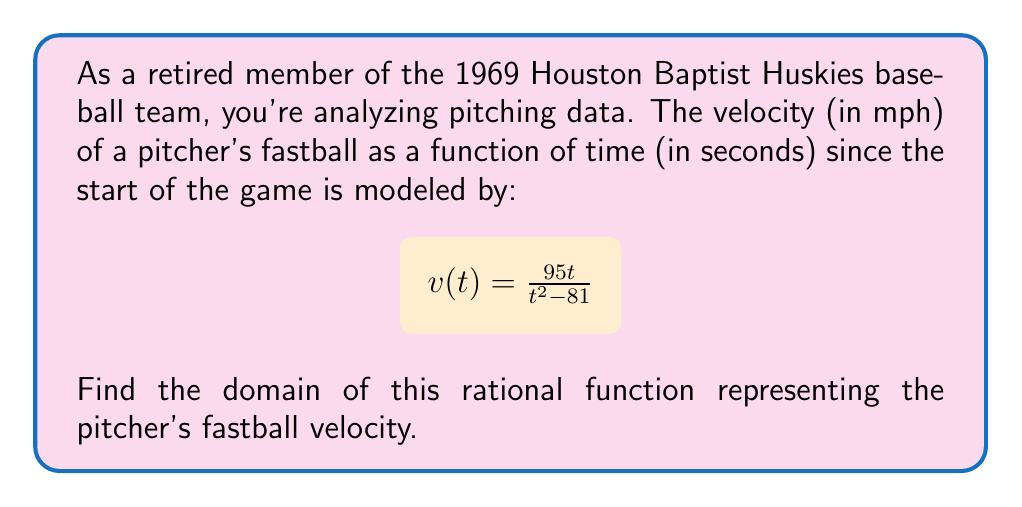Show me your answer to this math problem. To find the domain of this rational function, we need to consider where the function is defined. A rational function is undefined when its denominator equals zero.

1) First, set the denominator equal to zero:
   $$t^2 - 81 = 0$$

2) Solve this quadratic equation:
   $$t^2 = 81$$
   $$t = \pm \sqrt{81} = \pm 9$$

3) The function is undefined when $t = 9$ or $t = -9$.

4) Since time cannot be negative in this context, we only need to consider $t = 9$ as a restriction.

5) The domain of the function will be all real numbers except 9.

6) In interval notation, this is written as:
   $$(-\infty, 9) \cup (9, \infty)$$

This means the function is defined for all times except at exactly 9 seconds into the game, where the denominator would be zero.
Answer: $(-\infty, 9) \cup (9, \infty)$ 